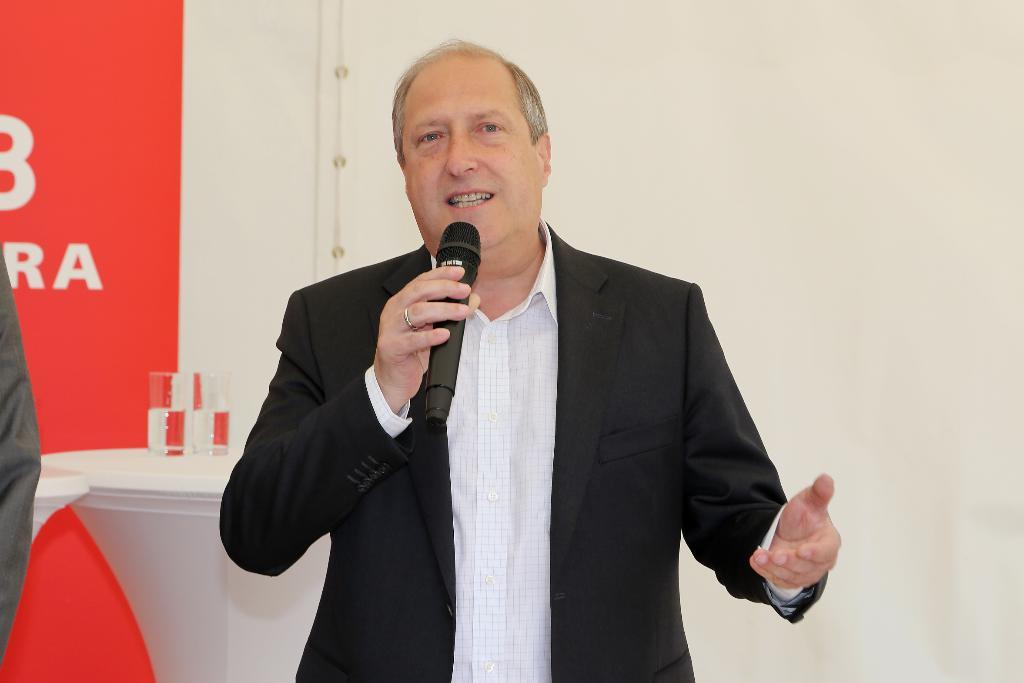Who is in the image? There is a man in the image. What is the man holding in the image? The man is holding a microphone. What is the man wearing in the image? The man is wearing a black suit. What can be seen in the background of the image? There is a wall in the background of the image. What is present in the image that might be used for drinking or eating? There are glasses present in the image. What type of sail can be seen in the image? There is no sail present in the image. Is the man performing an operation in the image? There is no indication of an operation being performed in the image. 